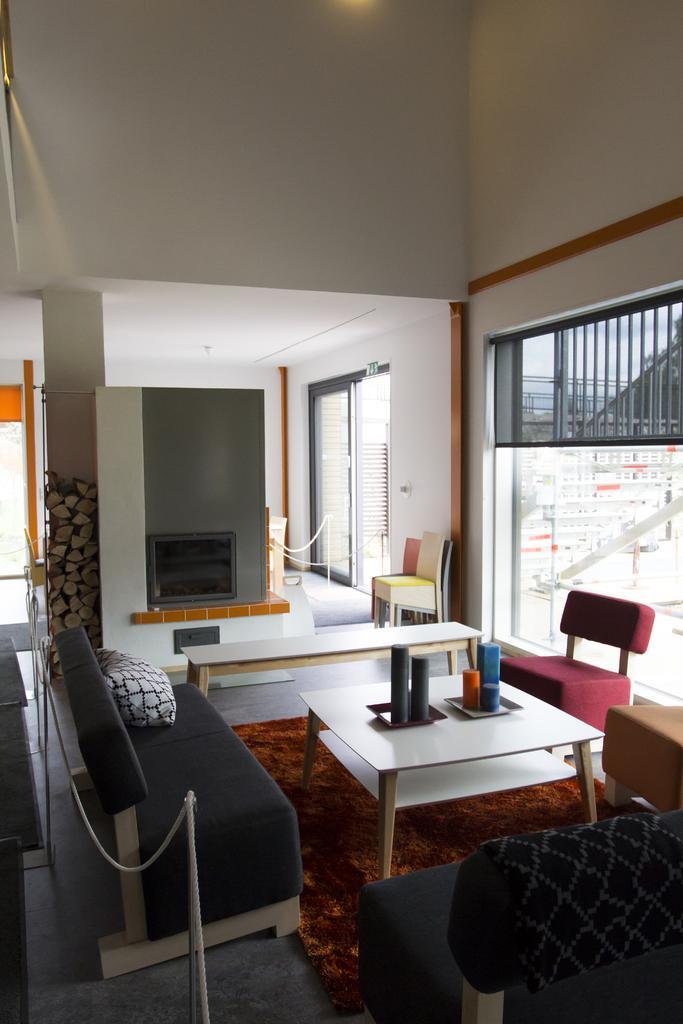Please provide a concise description of this image. In this picture we can see the inside view of a room. These are the sofas and there is a table. This is wall and these are the chairs. And there is a glass. 